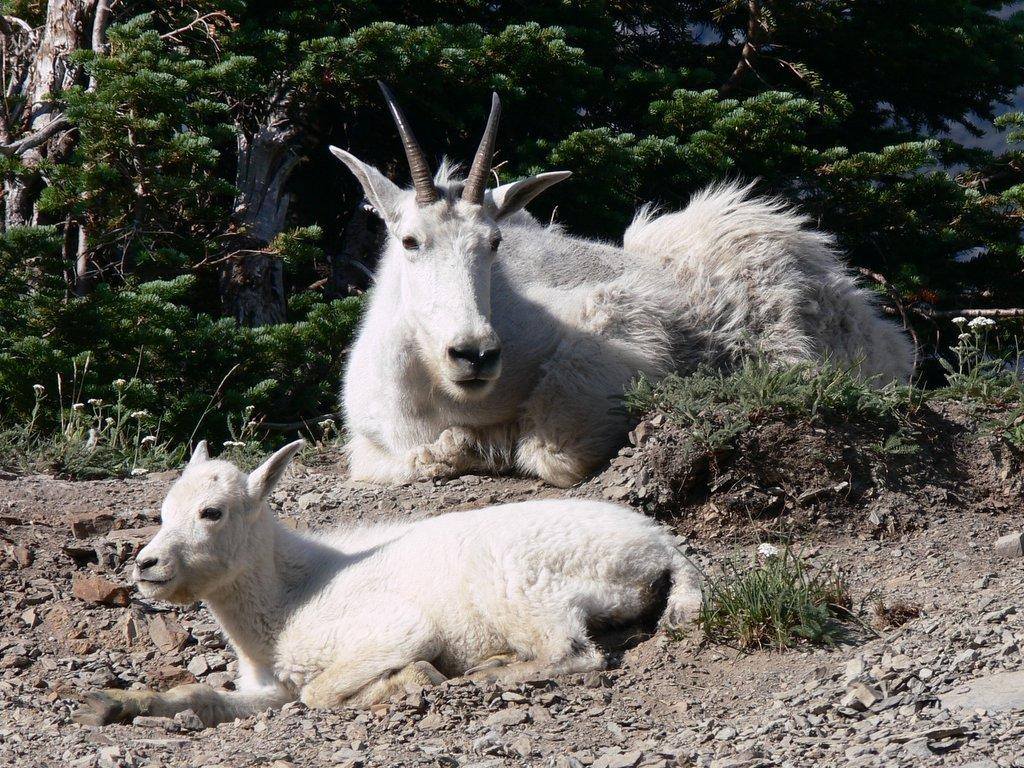What animals are present in the image? There are two white color mountain goats in the image. What are the mountain goats doing in the image? The mountain goats are sitting on the ground. What can be seen in the background of the image? There are trees visible in the background of the image. What type of ghost can be seen interacting with the mountain goats in the image? There are no ghosts present in the image; it features two white color mountain goats sitting on the ground with trees visible in the background. 